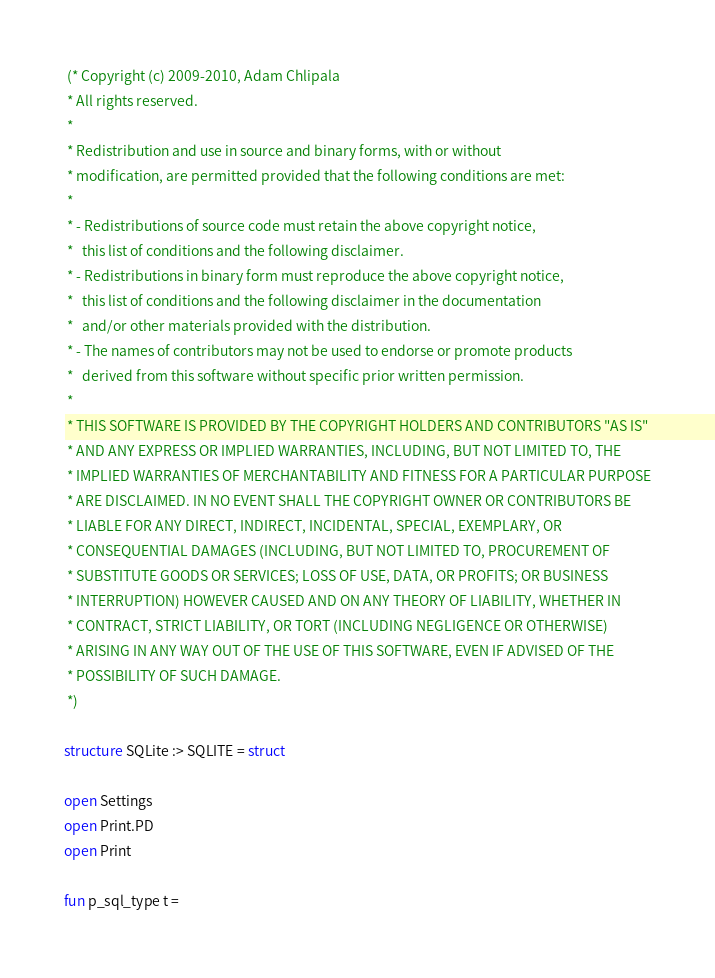Convert code to text. <code><loc_0><loc_0><loc_500><loc_500><_SML_> (* Copyright (c) 2009-2010, Adam Chlipala
 * All rights reserved.
 *
 * Redistribution and use in source and binary forms, with or without
 * modification, are permitted provided that the following conditions are met:
 *
 * - Redistributions of source code must retain the above copyright notice,
 *   this list of conditions and the following disclaimer.
 * - Redistributions in binary form must reproduce the above copyright notice,
 *   this list of conditions and the following disclaimer in the documentation
 *   and/or other materials provided with the distribution.
 * - The names of contributors may not be used to endorse or promote products
 *   derived from this software without specific prior written permission.
 *
 * THIS SOFTWARE IS PROVIDED BY THE COPYRIGHT HOLDERS AND CONTRIBUTORS "AS IS"
 * AND ANY EXPRESS OR IMPLIED WARRANTIES, INCLUDING, BUT NOT LIMITED TO, THE
 * IMPLIED WARRANTIES OF MERCHANTABILITY AND FITNESS FOR A PARTICULAR PURPOSE
 * ARE DISCLAIMED. IN NO EVENT SHALL THE COPYRIGHT OWNER OR CONTRIBUTORS BE
 * LIABLE FOR ANY DIRECT, INDIRECT, INCIDENTAL, SPECIAL, EXEMPLARY, OR
 * CONSEQUENTIAL DAMAGES (INCLUDING, BUT NOT LIMITED TO, PROCUREMENT OF
 * SUBSTITUTE GOODS OR SERVICES; LOSS OF USE, DATA, OR PROFITS; OR BUSINESS
 * INTERRUPTION) HOWEVER CAUSED AND ON ANY THEORY OF LIABILITY, WHETHER IN
 * CONTRACT, STRICT LIABILITY, OR TORT (INCLUDING NEGLIGENCE OR OTHERWISE)
 * ARISING IN ANY WAY OUT OF THE USE OF THIS SOFTWARE, EVEN IF ADVISED OF THE
 * POSSIBILITY OF SUCH DAMAGE.
 *)

structure SQLite :> SQLITE = struct

open Settings
open Print.PD
open Print

fun p_sql_type t =</code> 